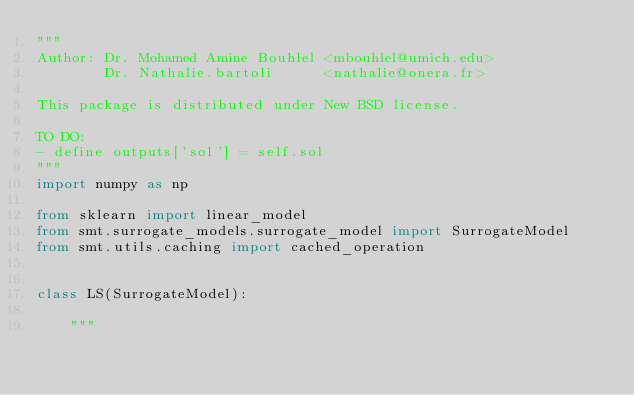Convert code to text. <code><loc_0><loc_0><loc_500><loc_500><_Python_>"""
Author: Dr. Mohamed Amine Bouhlel <mbouhlel@umich.edu>
        Dr. Nathalie.bartoli      <nathalie@onera.fr>

This package is distributed under New BSD license.

TO DO:
- define outputs['sol'] = self.sol
"""
import numpy as np

from sklearn import linear_model
from smt.surrogate_models.surrogate_model import SurrogateModel
from smt.utils.caching import cached_operation


class LS(SurrogateModel):

    """</code> 